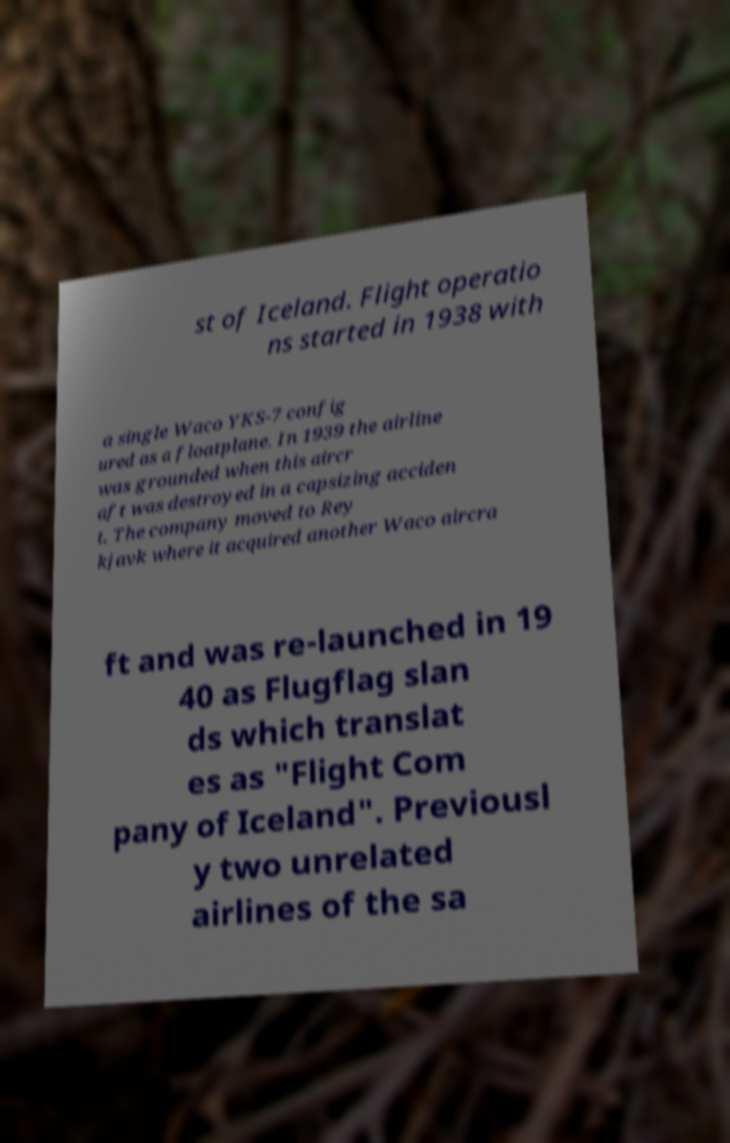What messages or text are displayed in this image? I need them in a readable, typed format. st of Iceland. Flight operatio ns started in 1938 with a single Waco YKS-7 config ured as a floatplane. In 1939 the airline was grounded when this aircr aft was destroyed in a capsizing acciden t. The company moved to Rey kjavk where it acquired another Waco aircra ft and was re-launched in 19 40 as Flugflag slan ds which translat es as "Flight Com pany of Iceland". Previousl y two unrelated airlines of the sa 